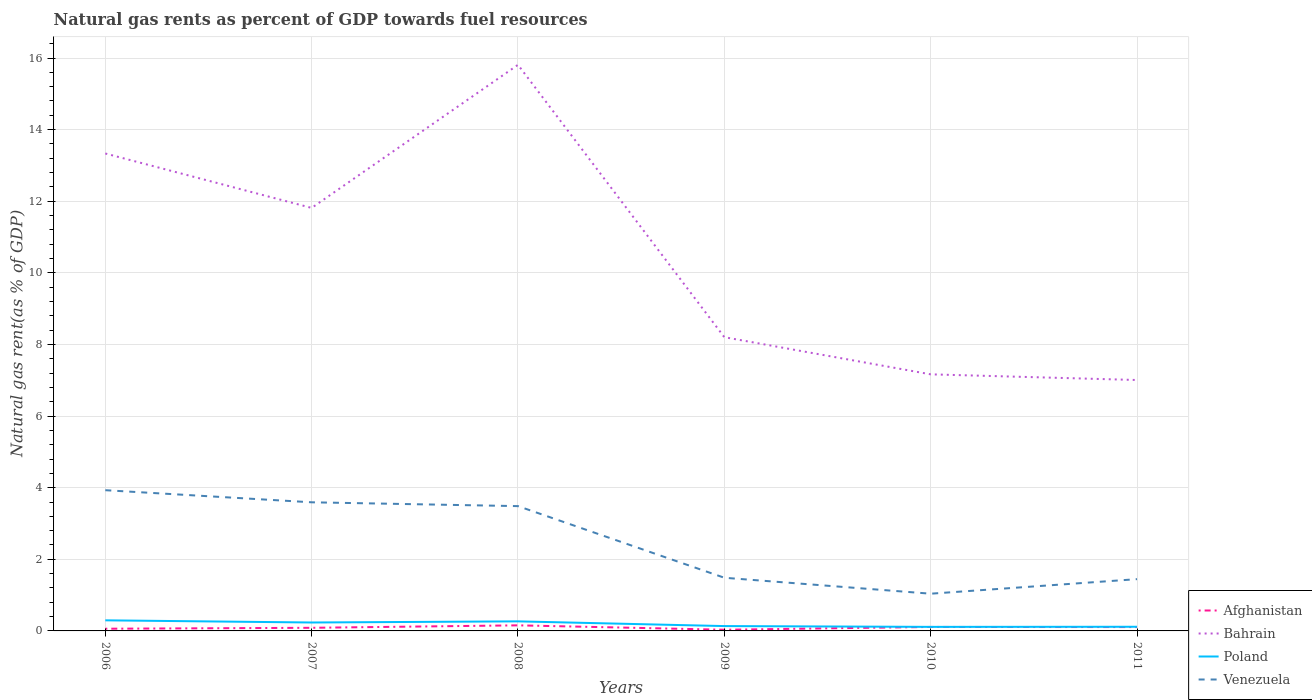Is the number of lines equal to the number of legend labels?
Your answer should be very brief. Yes. Across all years, what is the maximum natural gas rent in Bahrain?
Your answer should be compact. 7.01. What is the total natural gas rent in Venezuela in the graph?
Offer a terse response. 2.55. What is the difference between the highest and the second highest natural gas rent in Venezuela?
Keep it short and to the point. 2.89. What is the difference between the highest and the lowest natural gas rent in Poland?
Your response must be concise. 3. Is the natural gas rent in Afghanistan strictly greater than the natural gas rent in Bahrain over the years?
Your response must be concise. Yes. How many years are there in the graph?
Ensure brevity in your answer.  6. What is the difference between two consecutive major ticks on the Y-axis?
Provide a short and direct response. 2. Are the values on the major ticks of Y-axis written in scientific E-notation?
Ensure brevity in your answer.  No. Does the graph contain any zero values?
Make the answer very short. No. Does the graph contain grids?
Give a very brief answer. Yes. Where does the legend appear in the graph?
Provide a short and direct response. Bottom right. How many legend labels are there?
Your answer should be very brief. 4. What is the title of the graph?
Your response must be concise. Natural gas rents as percent of GDP towards fuel resources. Does "Seychelles" appear as one of the legend labels in the graph?
Make the answer very short. No. What is the label or title of the Y-axis?
Ensure brevity in your answer.  Natural gas rent(as % of GDP). What is the Natural gas rent(as % of GDP) of Afghanistan in 2006?
Make the answer very short. 0.06. What is the Natural gas rent(as % of GDP) in Bahrain in 2006?
Provide a succinct answer. 13.33. What is the Natural gas rent(as % of GDP) of Poland in 2006?
Your response must be concise. 0.3. What is the Natural gas rent(as % of GDP) of Venezuela in 2006?
Your answer should be very brief. 3.93. What is the Natural gas rent(as % of GDP) in Afghanistan in 2007?
Provide a succinct answer. 0.09. What is the Natural gas rent(as % of GDP) of Bahrain in 2007?
Your answer should be compact. 11.81. What is the Natural gas rent(as % of GDP) of Poland in 2007?
Your response must be concise. 0.24. What is the Natural gas rent(as % of GDP) of Venezuela in 2007?
Your answer should be compact. 3.59. What is the Natural gas rent(as % of GDP) in Afghanistan in 2008?
Provide a short and direct response. 0.16. What is the Natural gas rent(as % of GDP) of Bahrain in 2008?
Give a very brief answer. 15.81. What is the Natural gas rent(as % of GDP) of Poland in 2008?
Give a very brief answer. 0.27. What is the Natural gas rent(as % of GDP) in Venezuela in 2008?
Keep it short and to the point. 3.49. What is the Natural gas rent(as % of GDP) in Afghanistan in 2009?
Keep it short and to the point. 0.03. What is the Natural gas rent(as % of GDP) in Bahrain in 2009?
Your answer should be very brief. 8.2. What is the Natural gas rent(as % of GDP) in Poland in 2009?
Provide a short and direct response. 0.14. What is the Natural gas rent(as % of GDP) of Venezuela in 2009?
Provide a succinct answer. 1.48. What is the Natural gas rent(as % of GDP) of Afghanistan in 2010?
Offer a very short reply. 0.11. What is the Natural gas rent(as % of GDP) of Bahrain in 2010?
Your answer should be very brief. 7.17. What is the Natural gas rent(as % of GDP) of Poland in 2010?
Your answer should be very brief. 0.11. What is the Natural gas rent(as % of GDP) in Venezuela in 2010?
Offer a terse response. 1.04. What is the Natural gas rent(as % of GDP) in Afghanistan in 2011?
Your answer should be compact. 0.11. What is the Natural gas rent(as % of GDP) in Bahrain in 2011?
Provide a succinct answer. 7.01. What is the Natural gas rent(as % of GDP) in Poland in 2011?
Your answer should be very brief. 0.12. What is the Natural gas rent(as % of GDP) in Venezuela in 2011?
Offer a terse response. 1.45. Across all years, what is the maximum Natural gas rent(as % of GDP) of Afghanistan?
Keep it short and to the point. 0.16. Across all years, what is the maximum Natural gas rent(as % of GDP) in Bahrain?
Make the answer very short. 15.81. Across all years, what is the maximum Natural gas rent(as % of GDP) in Poland?
Provide a short and direct response. 0.3. Across all years, what is the maximum Natural gas rent(as % of GDP) of Venezuela?
Your response must be concise. 3.93. Across all years, what is the minimum Natural gas rent(as % of GDP) in Afghanistan?
Your answer should be compact. 0.03. Across all years, what is the minimum Natural gas rent(as % of GDP) in Bahrain?
Make the answer very short. 7.01. Across all years, what is the minimum Natural gas rent(as % of GDP) in Poland?
Offer a terse response. 0.11. Across all years, what is the minimum Natural gas rent(as % of GDP) in Venezuela?
Provide a succinct answer. 1.04. What is the total Natural gas rent(as % of GDP) of Afghanistan in the graph?
Keep it short and to the point. 0.56. What is the total Natural gas rent(as % of GDP) in Bahrain in the graph?
Make the answer very short. 63.33. What is the total Natural gas rent(as % of GDP) of Poland in the graph?
Offer a terse response. 1.16. What is the total Natural gas rent(as % of GDP) of Venezuela in the graph?
Your answer should be very brief. 14.98. What is the difference between the Natural gas rent(as % of GDP) of Afghanistan in 2006 and that in 2007?
Make the answer very short. -0.03. What is the difference between the Natural gas rent(as % of GDP) of Bahrain in 2006 and that in 2007?
Provide a short and direct response. 1.52. What is the difference between the Natural gas rent(as % of GDP) in Poland in 2006 and that in 2007?
Keep it short and to the point. 0.06. What is the difference between the Natural gas rent(as % of GDP) of Venezuela in 2006 and that in 2007?
Your answer should be very brief. 0.34. What is the difference between the Natural gas rent(as % of GDP) of Afghanistan in 2006 and that in 2008?
Your response must be concise. -0.09. What is the difference between the Natural gas rent(as % of GDP) in Bahrain in 2006 and that in 2008?
Ensure brevity in your answer.  -2.48. What is the difference between the Natural gas rent(as % of GDP) of Poland in 2006 and that in 2008?
Provide a short and direct response. 0.03. What is the difference between the Natural gas rent(as % of GDP) of Venezuela in 2006 and that in 2008?
Offer a terse response. 0.44. What is the difference between the Natural gas rent(as % of GDP) in Afghanistan in 2006 and that in 2009?
Ensure brevity in your answer.  0.03. What is the difference between the Natural gas rent(as % of GDP) of Bahrain in 2006 and that in 2009?
Give a very brief answer. 5.13. What is the difference between the Natural gas rent(as % of GDP) in Poland in 2006 and that in 2009?
Offer a terse response. 0.16. What is the difference between the Natural gas rent(as % of GDP) of Venezuela in 2006 and that in 2009?
Make the answer very short. 2.45. What is the difference between the Natural gas rent(as % of GDP) in Afghanistan in 2006 and that in 2010?
Provide a succinct answer. -0.05. What is the difference between the Natural gas rent(as % of GDP) of Bahrain in 2006 and that in 2010?
Offer a very short reply. 6.17. What is the difference between the Natural gas rent(as % of GDP) in Poland in 2006 and that in 2010?
Provide a succinct answer. 0.18. What is the difference between the Natural gas rent(as % of GDP) of Venezuela in 2006 and that in 2010?
Your response must be concise. 2.89. What is the difference between the Natural gas rent(as % of GDP) of Afghanistan in 2006 and that in 2011?
Offer a terse response. -0.05. What is the difference between the Natural gas rent(as % of GDP) of Bahrain in 2006 and that in 2011?
Provide a short and direct response. 6.33. What is the difference between the Natural gas rent(as % of GDP) in Poland in 2006 and that in 2011?
Keep it short and to the point. 0.18. What is the difference between the Natural gas rent(as % of GDP) in Venezuela in 2006 and that in 2011?
Provide a succinct answer. 2.48. What is the difference between the Natural gas rent(as % of GDP) in Afghanistan in 2007 and that in 2008?
Provide a short and direct response. -0.07. What is the difference between the Natural gas rent(as % of GDP) of Bahrain in 2007 and that in 2008?
Keep it short and to the point. -4. What is the difference between the Natural gas rent(as % of GDP) of Poland in 2007 and that in 2008?
Give a very brief answer. -0.03. What is the difference between the Natural gas rent(as % of GDP) in Venezuela in 2007 and that in 2008?
Provide a succinct answer. 0.11. What is the difference between the Natural gas rent(as % of GDP) of Afghanistan in 2007 and that in 2009?
Your answer should be compact. 0.05. What is the difference between the Natural gas rent(as % of GDP) of Bahrain in 2007 and that in 2009?
Your answer should be compact. 3.61. What is the difference between the Natural gas rent(as % of GDP) in Poland in 2007 and that in 2009?
Make the answer very short. 0.1. What is the difference between the Natural gas rent(as % of GDP) in Venezuela in 2007 and that in 2009?
Provide a short and direct response. 2.11. What is the difference between the Natural gas rent(as % of GDP) in Afghanistan in 2007 and that in 2010?
Your answer should be compact. -0.02. What is the difference between the Natural gas rent(as % of GDP) of Bahrain in 2007 and that in 2010?
Provide a short and direct response. 4.65. What is the difference between the Natural gas rent(as % of GDP) of Poland in 2007 and that in 2010?
Your answer should be very brief. 0.12. What is the difference between the Natural gas rent(as % of GDP) of Venezuela in 2007 and that in 2010?
Your response must be concise. 2.55. What is the difference between the Natural gas rent(as % of GDP) of Afghanistan in 2007 and that in 2011?
Your answer should be compact. -0.02. What is the difference between the Natural gas rent(as % of GDP) in Bahrain in 2007 and that in 2011?
Offer a very short reply. 4.81. What is the difference between the Natural gas rent(as % of GDP) of Poland in 2007 and that in 2011?
Provide a short and direct response. 0.12. What is the difference between the Natural gas rent(as % of GDP) in Venezuela in 2007 and that in 2011?
Provide a short and direct response. 2.15. What is the difference between the Natural gas rent(as % of GDP) in Afghanistan in 2008 and that in 2009?
Give a very brief answer. 0.12. What is the difference between the Natural gas rent(as % of GDP) of Bahrain in 2008 and that in 2009?
Keep it short and to the point. 7.61. What is the difference between the Natural gas rent(as % of GDP) of Poland in 2008 and that in 2009?
Give a very brief answer. 0.13. What is the difference between the Natural gas rent(as % of GDP) in Venezuela in 2008 and that in 2009?
Offer a very short reply. 2. What is the difference between the Natural gas rent(as % of GDP) in Afghanistan in 2008 and that in 2010?
Keep it short and to the point. 0.04. What is the difference between the Natural gas rent(as % of GDP) of Bahrain in 2008 and that in 2010?
Your response must be concise. 8.64. What is the difference between the Natural gas rent(as % of GDP) in Poland in 2008 and that in 2010?
Offer a very short reply. 0.15. What is the difference between the Natural gas rent(as % of GDP) of Venezuela in 2008 and that in 2010?
Ensure brevity in your answer.  2.45. What is the difference between the Natural gas rent(as % of GDP) of Afghanistan in 2008 and that in 2011?
Give a very brief answer. 0.05. What is the difference between the Natural gas rent(as % of GDP) in Bahrain in 2008 and that in 2011?
Ensure brevity in your answer.  8.8. What is the difference between the Natural gas rent(as % of GDP) of Poland in 2008 and that in 2011?
Offer a very short reply. 0.15. What is the difference between the Natural gas rent(as % of GDP) of Venezuela in 2008 and that in 2011?
Offer a very short reply. 2.04. What is the difference between the Natural gas rent(as % of GDP) in Afghanistan in 2009 and that in 2010?
Offer a very short reply. -0.08. What is the difference between the Natural gas rent(as % of GDP) in Bahrain in 2009 and that in 2010?
Provide a short and direct response. 1.04. What is the difference between the Natural gas rent(as % of GDP) in Poland in 2009 and that in 2010?
Keep it short and to the point. 0.02. What is the difference between the Natural gas rent(as % of GDP) of Venezuela in 2009 and that in 2010?
Provide a succinct answer. 0.45. What is the difference between the Natural gas rent(as % of GDP) in Afghanistan in 2009 and that in 2011?
Offer a very short reply. -0.07. What is the difference between the Natural gas rent(as % of GDP) in Bahrain in 2009 and that in 2011?
Give a very brief answer. 1.2. What is the difference between the Natural gas rent(as % of GDP) of Poland in 2009 and that in 2011?
Your response must be concise. 0.02. What is the difference between the Natural gas rent(as % of GDP) of Venezuela in 2009 and that in 2011?
Provide a succinct answer. 0.04. What is the difference between the Natural gas rent(as % of GDP) of Afghanistan in 2010 and that in 2011?
Give a very brief answer. 0. What is the difference between the Natural gas rent(as % of GDP) in Bahrain in 2010 and that in 2011?
Offer a terse response. 0.16. What is the difference between the Natural gas rent(as % of GDP) of Poland in 2010 and that in 2011?
Offer a very short reply. -0. What is the difference between the Natural gas rent(as % of GDP) in Venezuela in 2010 and that in 2011?
Give a very brief answer. -0.41. What is the difference between the Natural gas rent(as % of GDP) in Afghanistan in 2006 and the Natural gas rent(as % of GDP) in Bahrain in 2007?
Offer a very short reply. -11.75. What is the difference between the Natural gas rent(as % of GDP) in Afghanistan in 2006 and the Natural gas rent(as % of GDP) in Poland in 2007?
Offer a very short reply. -0.17. What is the difference between the Natural gas rent(as % of GDP) of Afghanistan in 2006 and the Natural gas rent(as % of GDP) of Venezuela in 2007?
Your response must be concise. -3.53. What is the difference between the Natural gas rent(as % of GDP) in Bahrain in 2006 and the Natural gas rent(as % of GDP) in Poland in 2007?
Your answer should be compact. 13.1. What is the difference between the Natural gas rent(as % of GDP) in Bahrain in 2006 and the Natural gas rent(as % of GDP) in Venezuela in 2007?
Offer a very short reply. 9.74. What is the difference between the Natural gas rent(as % of GDP) in Poland in 2006 and the Natural gas rent(as % of GDP) in Venezuela in 2007?
Give a very brief answer. -3.3. What is the difference between the Natural gas rent(as % of GDP) in Afghanistan in 2006 and the Natural gas rent(as % of GDP) in Bahrain in 2008?
Your answer should be very brief. -15.75. What is the difference between the Natural gas rent(as % of GDP) of Afghanistan in 2006 and the Natural gas rent(as % of GDP) of Poland in 2008?
Provide a short and direct response. -0.21. What is the difference between the Natural gas rent(as % of GDP) in Afghanistan in 2006 and the Natural gas rent(as % of GDP) in Venezuela in 2008?
Keep it short and to the point. -3.42. What is the difference between the Natural gas rent(as % of GDP) in Bahrain in 2006 and the Natural gas rent(as % of GDP) in Poland in 2008?
Offer a very short reply. 13.07. What is the difference between the Natural gas rent(as % of GDP) of Bahrain in 2006 and the Natural gas rent(as % of GDP) of Venezuela in 2008?
Your answer should be very brief. 9.85. What is the difference between the Natural gas rent(as % of GDP) in Poland in 2006 and the Natural gas rent(as % of GDP) in Venezuela in 2008?
Make the answer very short. -3.19. What is the difference between the Natural gas rent(as % of GDP) of Afghanistan in 2006 and the Natural gas rent(as % of GDP) of Bahrain in 2009?
Provide a succinct answer. -8.14. What is the difference between the Natural gas rent(as % of GDP) of Afghanistan in 2006 and the Natural gas rent(as % of GDP) of Poland in 2009?
Your response must be concise. -0.07. What is the difference between the Natural gas rent(as % of GDP) of Afghanistan in 2006 and the Natural gas rent(as % of GDP) of Venezuela in 2009?
Your answer should be compact. -1.42. What is the difference between the Natural gas rent(as % of GDP) in Bahrain in 2006 and the Natural gas rent(as % of GDP) in Poland in 2009?
Provide a succinct answer. 13.2. What is the difference between the Natural gas rent(as % of GDP) of Bahrain in 2006 and the Natural gas rent(as % of GDP) of Venezuela in 2009?
Your answer should be very brief. 11.85. What is the difference between the Natural gas rent(as % of GDP) in Poland in 2006 and the Natural gas rent(as % of GDP) in Venezuela in 2009?
Keep it short and to the point. -1.19. What is the difference between the Natural gas rent(as % of GDP) in Afghanistan in 2006 and the Natural gas rent(as % of GDP) in Bahrain in 2010?
Make the answer very short. -7.1. What is the difference between the Natural gas rent(as % of GDP) of Afghanistan in 2006 and the Natural gas rent(as % of GDP) of Poland in 2010?
Ensure brevity in your answer.  -0.05. What is the difference between the Natural gas rent(as % of GDP) in Afghanistan in 2006 and the Natural gas rent(as % of GDP) in Venezuela in 2010?
Provide a succinct answer. -0.98. What is the difference between the Natural gas rent(as % of GDP) of Bahrain in 2006 and the Natural gas rent(as % of GDP) of Poland in 2010?
Your answer should be very brief. 13.22. What is the difference between the Natural gas rent(as % of GDP) of Bahrain in 2006 and the Natural gas rent(as % of GDP) of Venezuela in 2010?
Provide a short and direct response. 12.29. What is the difference between the Natural gas rent(as % of GDP) in Poland in 2006 and the Natural gas rent(as % of GDP) in Venezuela in 2010?
Ensure brevity in your answer.  -0.74. What is the difference between the Natural gas rent(as % of GDP) of Afghanistan in 2006 and the Natural gas rent(as % of GDP) of Bahrain in 2011?
Your answer should be compact. -6.95. What is the difference between the Natural gas rent(as % of GDP) of Afghanistan in 2006 and the Natural gas rent(as % of GDP) of Poland in 2011?
Your response must be concise. -0.05. What is the difference between the Natural gas rent(as % of GDP) of Afghanistan in 2006 and the Natural gas rent(as % of GDP) of Venezuela in 2011?
Give a very brief answer. -1.38. What is the difference between the Natural gas rent(as % of GDP) of Bahrain in 2006 and the Natural gas rent(as % of GDP) of Poland in 2011?
Ensure brevity in your answer.  13.22. What is the difference between the Natural gas rent(as % of GDP) in Bahrain in 2006 and the Natural gas rent(as % of GDP) in Venezuela in 2011?
Keep it short and to the point. 11.89. What is the difference between the Natural gas rent(as % of GDP) of Poland in 2006 and the Natural gas rent(as % of GDP) of Venezuela in 2011?
Offer a very short reply. -1.15. What is the difference between the Natural gas rent(as % of GDP) of Afghanistan in 2007 and the Natural gas rent(as % of GDP) of Bahrain in 2008?
Offer a terse response. -15.72. What is the difference between the Natural gas rent(as % of GDP) in Afghanistan in 2007 and the Natural gas rent(as % of GDP) in Poland in 2008?
Provide a short and direct response. -0.18. What is the difference between the Natural gas rent(as % of GDP) of Afghanistan in 2007 and the Natural gas rent(as % of GDP) of Venezuela in 2008?
Make the answer very short. -3.4. What is the difference between the Natural gas rent(as % of GDP) of Bahrain in 2007 and the Natural gas rent(as % of GDP) of Poland in 2008?
Provide a short and direct response. 11.55. What is the difference between the Natural gas rent(as % of GDP) in Bahrain in 2007 and the Natural gas rent(as % of GDP) in Venezuela in 2008?
Your answer should be very brief. 8.33. What is the difference between the Natural gas rent(as % of GDP) in Poland in 2007 and the Natural gas rent(as % of GDP) in Venezuela in 2008?
Keep it short and to the point. -3.25. What is the difference between the Natural gas rent(as % of GDP) in Afghanistan in 2007 and the Natural gas rent(as % of GDP) in Bahrain in 2009?
Offer a very short reply. -8.12. What is the difference between the Natural gas rent(as % of GDP) in Afghanistan in 2007 and the Natural gas rent(as % of GDP) in Poland in 2009?
Give a very brief answer. -0.05. What is the difference between the Natural gas rent(as % of GDP) of Afghanistan in 2007 and the Natural gas rent(as % of GDP) of Venezuela in 2009?
Your answer should be compact. -1.4. What is the difference between the Natural gas rent(as % of GDP) of Bahrain in 2007 and the Natural gas rent(as % of GDP) of Poland in 2009?
Offer a very short reply. 11.68. What is the difference between the Natural gas rent(as % of GDP) in Bahrain in 2007 and the Natural gas rent(as % of GDP) in Venezuela in 2009?
Give a very brief answer. 10.33. What is the difference between the Natural gas rent(as % of GDP) of Poland in 2007 and the Natural gas rent(as % of GDP) of Venezuela in 2009?
Your response must be concise. -1.25. What is the difference between the Natural gas rent(as % of GDP) of Afghanistan in 2007 and the Natural gas rent(as % of GDP) of Bahrain in 2010?
Ensure brevity in your answer.  -7.08. What is the difference between the Natural gas rent(as % of GDP) of Afghanistan in 2007 and the Natural gas rent(as % of GDP) of Poland in 2010?
Provide a succinct answer. -0.03. What is the difference between the Natural gas rent(as % of GDP) in Afghanistan in 2007 and the Natural gas rent(as % of GDP) in Venezuela in 2010?
Give a very brief answer. -0.95. What is the difference between the Natural gas rent(as % of GDP) of Bahrain in 2007 and the Natural gas rent(as % of GDP) of Poland in 2010?
Your answer should be very brief. 11.7. What is the difference between the Natural gas rent(as % of GDP) of Bahrain in 2007 and the Natural gas rent(as % of GDP) of Venezuela in 2010?
Make the answer very short. 10.77. What is the difference between the Natural gas rent(as % of GDP) in Poland in 2007 and the Natural gas rent(as % of GDP) in Venezuela in 2010?
Offer a terse response. -0.8. What is the difference between the Natural gas rent(as % of GDP) in Afghanistan in 2007 and the Natural gas rent(as % of GDP) in Bahrain in 2011?
Ensure brevity in your answer.  -6.92. What is the difference between the Natural gas rent(as % of GDP) in Afghanistan in 2007 and the Natural gas rent(as % of GDP) in Poland in 2011?
Offer a very short reply. -0.03. What is the difference between the Natural gas rent(as % of GDP) in Afghanistan in 2007 and the Natural gas rent(as % of GDP) in Venezuela in 2011?
Your response must be concise. -1.36. What is the difference between the Natural gas rent(as % of GDP) in Bahrain in 2007 and the Natural gas rent(as % of GDP) in Poland in 2011?
Offer a very short reply. 11.7. What is the difference between the Natural gas rent(as % of GDP) in Bahrain in 2007 and the Natural gas rent(as % of GDP) in Venezuela in 2011?
Offer a very short reply. 10.37. What is the difference between the Natural gas rent(as % of GDP) in Poland in 2007 and the Natural gas rent(as % of GDP) in Venezuela in 2011?
Offer a terse response. -1.21. What is the difference between the Natural gas rent(as % of GDP) of Afghanistan in 2008 and the Natural gas rent(as % of GDP) of Bahrain in 2009?
Keep it short and to the point. -8.05. What is the difference between the Natural gas rent(as % of GDP) of Afghanistan in 2008 and the Natural gas rent(as % of GDP) of Poland in 2009?
Provide a succinct answer. 0.02. What is the difference between the Natural gas rent(as % of GDP) of Afghanistan in 2008 and the Natural gas rent(as % of GDP) of Venezuela in 2009?
Offer a terse response. -1.33. What is the difference between the Natural gas rent(as % of GDP) of Bahrain in 2008 and the Natural gas rent(as % of GDP) of Poland in 2009?
Your answer should be very brief. 15.67. What is the difference between the Natural gas rent(as % of GDP) in Bahrain in 2008 and the Natural gas rent(as % of GDP) in Venezuela in 2009?
Keep it short and to the point. 14.32. What is the difference between the Natural gas rent(as % of GDP) of Poland in 2008 and the Natural gas rent(as % of GDP) of Venezuela in 2009?
Offer a very short reply. -1.22. What is the difference between the Natural gas rent(as % of GDP) in Afghanistan in 2008 and the Natural gas rent(as % of GDP) in Bahrain in 2010?
Keep it short and to the point. -7.01. What is the difference between the Natural gas rent(as % of GDP) in Afghanistan in 2008 and the Natural gas rent(as % of GDP) in Poland in 2010?
Your answer should be very brief. 0.04. What is the difference between the Natural gas rent(as % of GDP) in Afghanistan in 2008 and the Natural gas rent(as % of GDP) in Venezuela in 2010?
Your answer should be compact. -0.88. What is the difference between the Natural gas rent(as % of GDP) of Bahrain in 2008 and the Natural gas rent(as % of GDP) of Poland in 2010?
Your answer should be very brief. 15.7. What is the difference between the Natural gas rent(as % of GDP) of Bahrain in 2008 and the Natural gas rent(as % of GDP) of Venezuela in 2010?
Your response must be concise. 14.77. What is the difference between the Natural gas rent(as % of GDP) of Poland in 2008 and the Natural gas rent(as % of GDP) of Venezuela in 2010?
Make the answer very short. -0.77. What is the difference between the Natural gas rent(as % of GDP) of Afghanistan in 2008 and the Natural gas rent(as % of GDP) of Bahrain in 2011?
Provide a succinct answer. -6.85. What is the difference between the Natural gas rent(as % of GDP) in Afghanistan in 2008 and the Natural gas rent(as % of GDP) in Poland in 2011?
Your answer should be compact. 0.04. What is the difference between the Natural gas rent(as % of GDP) of Afghanistan in 2008 and the Natural gas rent(as % of GDP) of Venezuela in 2011?
Give a very brief answer. -1.29. What is the difference between the Natural gas rent(as % of GDP) in Bahrain in 2008 and the Natural gas rent(as % of GDP) in Poland in 2011?
Provide a short and direct response. 15.69. What is the difference between the Natural gas rent(as % of GDP) of Bahrain in 2008 and the Natural gas rent(as % of GDP) of Venezuela in 2011?
Offer a very short reply. 14.36. What is the difference between the Natural gas rent(as % of GDP) of Poland in 2008 and the Natural gas rent(as % of GDP) of Venezuela in 2011?
Ensure brevity in your answer.  -1.18. What is the difference between the Natural gas rent(as % of GDP) in Afghanistan in 2009 and the Natural gas rent(as % of GDP) in Bahrain in 2010?
Give a very brief answer. -7.13. What is the difference between the Natural gas rent(as % of GDP) of Afghanistan in 2009 and the Natural gas rent(as % of GDP) of Poland in 2010?
Your answer should be compact. -0.08. What is the difference between the Natural gas rent(as % of GDP) of Afghanistan in 2009 and the Natural gas rent(as % of GDP) of Venezuela in 2010?
Make the answer very short. -1.01. What is the difference between the Natural gas rent(as % of GDP) of Bahrain in 2009 and the Natural gas rent(as % of GDP) of Poland in 2010?
Your answer should be very brief. 8.09. What is the difference between the Natural gas rent(as % of GDP) of Bahrain in 2009 and the Natural gas rent(as % of GDP) of Venezuela in 2010?
Your response must be concise. 7.16. What is the difference between the Natural gas rent(as % of GDP) of Poland in 2009 and the Natural gas rent(as % of GDP) of Venezuela in 2010?
Provide a succinct answer. -0.9. What is the difference between the Natural gas rent(as % of GDP) in Afghanistan in 2009 and the Natural gas rent(as % of GDP) in Bahrain in 2011?
Your answer should be compact. -6.97. What is the difference between the Natural gas rent(as % of GDP) of Afghanistan in 2009 and the Natural gas rent(as % of GDP) of Poland in 2011?
Make the answer very short. -0.08. What is the difference between the Natural gas rent(as % of GDP) in Afghanistan in 2009 and the Natural gas rent(as % of GDP) in Venezuela in 2011?
Provide a succinct answer. -1.41. What is the difference between the Natural gas rent(as % of GDP) of Bahrain in 2009 and the Natural gas rent(as % of GDP) of Poland in 2011?
Ensure brevity in your answer.  8.09. What is the difference between the Natural gas rent(as % of GDP) of Bahrain in 2009 and the Natural gas rent(as % of GDP) of Venezuela in 2011?
Make the answer very short. 6.76. What is the difference between the Natural gas rent(as % of GDP) in Poland in 2009 and the Natural gas rent(as % of GDP) in Venezuela in 2011?
Offer a very short reply. -1.31. What is the difference between the Natural gas rent(as % of GDP) of Afghanistan in 2010 and the Natural gas rent(as % of GDP) of Bahrain in 2011?
Offer a very short reply. -6.9. What is the difference between the Natural gas rent(as % of GDP) of Afghanistan in 2010 and the Natural gas rent(as % of GDP) of Poland in 2011?
Your response must be concise. -0.01. What is the difference between the Natural gas rent(as % of GDP) in Afghanistan in 2010 and the Natural gas rent(as % of GDP) in Venezuela in 2011?
Your response must be concise. -1.34. What is the difference between the Natural gas rent(as % of GDP) in Bahrain in 2010 and the Natural gas rent(as % of GDP) in Poland in 2011?
Offer a very short reply. 7.05. What is the difference between the Natural gas rent(as % of GDP) of Bahrain in 2010 and the Natural gas rent(as % of GDP) of Venezuela in 2011?
Provide a succinct answer. 5.72. What is the difference between the Natural gas rent(as % of GDP) in Poland in 2010 and the Natural gas rent(as % of GDP) in Venezuela in 2011?
Your answer should be very brief. -1.33. What is the average Natural gas rent(as % of GDP) of Afghanistan per year?
Ensure brevity in your answer.  0.09. What is the average Natural gas rent(as % of GDP) in Bahrain per year?
Offer a terse response. 10.56. What is the average Natural gas rent(as % of GDP) of Poland per year?
Your answer should be compact. 0.19. What is the average Natural gas rent(as % of GDP) in Venezuela per year?
Give a very brief answer. 2.5. In the year 2006, what is the difference between the Natural gas rent(as % of GDP) of Afghanistan and Natural gas rent(as % of GDP) of Bahrain?
Offer a very short reply. -13.27. In the year 2006, what is the difference between the Natural gas rent(as % of GDP) in Afghanistan and Natural gas rent(as % of GDP) in Poland?
Make the answer very short. -0.23. In the year 2006, what is the difference between the Natural gas rent(as % of GDP) of Afghanistan and Natural gas rent(as % of GDP) of Venezuela?
Make the answer very short. -3.87. In the year 2006, what is the difference between the Natural gas rent(as % of GDP) of Bahrain and Natural gas rent(as % of GDP) of Poland?
Keep it short and to the point. 13.04. In the year 2006, what is the difference between the Natural gas rent(as % of GDP) in Bahrain and Natural gas rent(as % of GDP) in Venezuela?
Your answer should be compact. 9.4. In the year 2006, what is the difference between the Natural gas rent(as % of GDP) of Poland and Natural gas rent(as % of GDP) of Venezuela?
Make the answer very short. -3.63. In the year 2007, what is the difference between the Natural gas rent(as % of GDP) in Afghanistan and Natural gas rent(as % of GDP) in Bahrain?
Offer a terse response. -11.73. In the year 2007, what is the difference between the Natural gas rent(as % of GDP) in Afghanistan and Natural gas rent(as % of GDP) in Poland?
Keep it short and to the point. -0.15. In the year 2007, what is the difference between the Natural gas rent(as % of GDP) of Afghanistan and Natural gas rent(as % of GDP) of Venezuela?
Keep it short and to the point. -3.5. In the year 2007, what is the difference between the Natural gas rent(as % of GDP) in Bahrain and Natural gas rent(as % of GDP) in Poland?
Your response must be concise. 11.58. In the year 2007, what is the difference between the Natural gas rent(as % of GDP) in Bahrain and Natural gas rent(as % of GDP) in Venezuela?
Offer a very short reply. 8.22. In the year 2007, what is the difference between the Natural gas rent(as % of GDP) of Poland and Natural gas rent(as % of GDP) of Venezuela?
Your response must be concise. -3.36. In the year 2008, what is the difference between the Natural gas rent(as % of GDP) of Afghanistan and Natural gas rent(as % of GDP) of Bahrain?
Give a very brief answer. -15.65. In the year 2008, what is the difference between the Natural gas rent(as % of GDP) in Afghanistan and Natural gas rent(as % of GDP) in Poland?
Provide a succinct answer. -0.11. In the year 2008, what is the difference between the Natural gas rent(as % of GDP) of Afghanistan and Natural gas rent(as % of GDP) of Venezuela?
Keep it short and to the point. -3.33. In the year 2008, what is the difference between the Natural gas rent(as % of GDP) of Bahrain and Natural gas rent(as % of GDP) of Poland?
Your answer should be compact. 15.54. In the year 2008, what is the difference between the Natural gas rent(as % of GDP) in Bahrain and Natural gas rent(as % of GDP) in Venezuela?
Your answer should be very brief. 12.32. In the year 2008, what is the difference between the Natural gas rent(as % of GDP) in Poland and Natural gas rent(as % of GDP) in Venezuela?
Keep it short and to the point. -3.22. In the year 2009, what is the difference between the Natural gas rent(as % of GDP) in Afghanistan and Natural gas rent(as % of GDP) in Bahrain?
Make the answer very short. -8.17. In the year 2009, what is the difference between the Natural gas rent(as % of GDP) in Afghanistan and Natural gas rent(as % of GDP) in Poland?
Your answer should be compact. -0.1. In the year 2009, what is the difference between the Natural gas rent(as % of GDP) of Afghanistan and Natural gas rent(as % of GDP) of Venezuela?
Offer a terse response. -1.45. In the year 2009, what is the difference between the Natural gas rent(as % of GDP) in Bahrain and Natural gas rent(as % of GDP) in Poland?
Ensure brevity in your answer.  8.07. In the year 2009, what is the difference between the Natural gas rent(as % of GDP) in Bahrain and Natural gas rent(as % of GDP) in Venezuela?
Make the answer very short. 6.72. In the year 2009, what is the difference between the Natural gas rent(as % of GDP) in Poland and Natural gas rent(as % of GDP) in Venezuela?
Give a very brief answer. -1.35. In the year 2010, what is the difference between the Natural gas rent(as % of GDP) of Afghanistan and Natural gas rent(as % of GDP) of Bahrain?
Make the answer very short. -7.05. In the year 2010, what is the difference between the Natural gas rent(as % of GDP) of Afghanistan and Natural gas rent(as % of GDP) of Poland?
Make the answer very short. -0. In the year 2010, what is the difference between the Natural gas rent(as % of GDP) of Afghanistan and Natural gas rent(as % of GDP) of Venezuela?
Offer a terse response. -0.93. In the year 2010, what is the difference between the Natural gas rent(as % of GDP) in Bahrain and Natural gas rent(as % of GDP) in Poland?
Make the answer very short. 7.05. In the year 2010, what is the difference between the Natural gas rent(as % of GDP) of Bahrain and Natural gas rent(as % of GDP) of Venezuela?
Ensure brevity in your answer.  6.13. In the year 2010, what is the difference between the Natural gas rent(as % of GDP) in Poland and Natural gas rent(as % of GDP) in Venezuela?
Provide a succinct answer. -0.93. In the year 2011, what is the difference between the Natural gas rent(as % of GDP) of Afghanistan and Natural gas rent(as % of GDP) of Bahrain?
Keep it short and to the point. -6.9. In the year 2011, what is the difference between the Natural gas rent(as % of GDP) in Afghanistan and Natural gas rent(as % of GDP) in Poland?
Your answer should be compact. -0.01. In the year 2011, what is the difference between the Natural gas rent(as % of GDP) in Afghanistan and Natural gas rent(as % of GDP) in Venezuela?
Keep it short and to the point. -1.34. In the year 2011, what is the difference between the Natural gas rent(as % of GDP) in Bahrain and Natural gas rent(as % of GDP) in Poland?
Offer a very short reply. 6.89. In the year 2011, what is the difference between the Natural gas rent(as % of GDP) in Bahrain and Natural gas rent(as % of GDP) in Venezuela?
Provide a short and direct response. 5.56. In the year 2011, what is the difference between the Natural gas rent(as % of GDP) of Poland and Natural gas rent(as % of GDP) of Venezuela?
Your answer should be very brief. -1.33. What is the ratio of the Natural gas rent(as % of GDP) in Afghanistan in 2006 to that in 2007?
Keep it short and to the point. 0.7. What is the ratio of the Natural gas rent(as % of GDP) in Bahrain in 2006 to that in 2007?
Provide a short and direct response. 1.13. What is the ratio of the Natural gas rent(as % of GDP) of Poland in 2006 to that in 2007?
Your answer should be compact. 1.26. What is the ratio of the Natural gas rent(as % of GDP) in Venezuela in 2006 to that in 2007?
Ensure brevity in your answer.  1.09. What is the ratio of the Natural gas rent(as % of GDP) of Afghanistan in 2006 to that in 2008?
Provide a succinct answer. 0.39. What is the ratio of the Natural gas rent(as % of GDP) of Bahrain in 2006 to that in 2008?
Offer a very short reply. 0.84. What is the ratio of the Natural gas rent(as % of GDP) in Poland in 2006 to that in 2008?
Offer a terse response. 1.11. What is the ratio of the Natural gas rent(as % of GDP) of Venezuela in 2006 to that in 2008?
Provide a short and direct response. 1.13. What is the ratio of the Natural gas rent(as % of GDP) in Afghanistan in 2006 to that in 2009?
Ensure brevity in your answer.  1.86. What is the ratio of the Natural gas rent(as % of GDP) of Bahrain in 2006 to that in 2009?
Offer a very short reply. 1.63. What is the ratio of the Natural gas rent(as % of GDP) in Poland in 2006 to that in 2009?
Offer a very short reply. 2.19. What is the ratio of the Natural gas rent(as % of GDP) of Venezuela in 2006 to that in 2009?
Offer a very short reply. 2.65. What is the ratio of the Natural gas rent(as % of GDP) of Afghanistan in 2006 to that in 2010?
Your response must be concise. 0.55. What is the ratio of the Natural gas rent(as % of GDP) of Bahrain in 2006 to that in 2010?
Your answer should be very brief. 1.86. What is the ratio of the Natural gas rent(as % of GDP) in Poland in 2006 to that in 2010?
Offer a very short reply. 2.62. What is the ratio of the Natural gas rent(as % of GDP) of Venezuela in 2006 to that in 2010?
Make the answer very short. 3.78. What is the ratio of the Natural gas rent(as % of GDP) in Afghanistan in 2006 to that in 2011?
Keep it short and to the point. 0.57. What is the ratio of the Natural gas rent(as % of GDP) of Bahrain in 2006 to that in 2011?
Your response must be concise. 1.9. What is the ratio of the Natural gas rent(as % of GDP) in Poland in 2006 to that in 2011?
Keep it short and to the point. 2.55. What is the ratio of the Natural gas rent(as % of GDP) in Venezuela in 2006 to that in 2011?
Your answer should be compact. 2.72. What is the ratio of the Natural gas rent(as % of GDP) of Afghanistan in 2007 to that in 2008?
Give a very brief answer. 0.56. What is the ratio of the Natural gas rent(as % of GDP) in Bahrain in 2007 to that in 2008?
Provide a short and direct response. 0.75. What is the ratio of the Natural gas rent(as % of GDP) of Poland in 2007 to that in 2008?
Keep it short and to the point. 0.88. What is the ratio of the Natural gas rent(as % of GDP) of Venezuela in 2007 to that in 2008?
Provide a succinct answer. 1.03. What is the ratio of the Natural gas rent(as % of GDP) in Afghanistan in 2007 to that in 2009?
Ensure brevity in your answer.  2.64. What is the ratio of the Natural gas rent(as % of GDP) in Bahrain in 2007 to that in 2009?
Ensure brevity in your answer.  1.44. What is the ratio of the Natural gas rent(as % of GDP) of Poland in 2007 to that in 2009?
Make the answer very short. 1.74. What is the ratio of the Natural gas rent(as % of GDP) in Venezuela in 2007 to that in 2009?
Offer a terse response. 2.42. What is the ratio of the Natural gas rent(as % of GDP) of Afghanistan in 2007 to that in 2010?
Offer a terse response. 0.79. What is the ratio of the Natural gas rent(as % of GDP) of Bahrain in 2007 to that in 2010?
Ensure brevity in your answer.  1.65. What is the ratio of the Natural gas rent(as % of GDP) of Poland in 2007 to that in 2010?
Your response must be concise. 2.08. What is the ratio of the Natural gas rent(as % of GDP) in Venezuela in 2007 to that in 2010?
Provide a short and direct response. 3.46. What is the ratio of the Natural gas rent(as % of GDP) of Afghanistan in 2007 to that in 2011?
Offer a terse response. 0.81. What is the ratio of the Natural gas rent(as % of GDP) in Bahrain in 2007 to that in 2011?
Your response must be concise. 1.69. What is the ratio of the Natural gas rent(as % of GDP) of Poland in 2007 to that in 2011?
Your answer should be compact. 2.02. What is the ratio of the Natural gas rent(as % of GDP) in Venezuela in 2007 to that in 2011?
Your response must be concise. 2.48. What is the ratio of the Natural gas rent(as % of GDP) of Afghanistan in 2008 to that in 2009?
Your answer should be compact. 4.72. What is the ratio of the Natural gas rent(as % of GDP) in Bahrain in 2008 to that in 2009?
Your answer should be very brief. 1.93. What is the ratio of the Natural gas rent(as % of GDP) of Poland in 2008 to that in 2009?
Ensure brevity in your answer.  1.97. What is the ratio of the Natural gas rent(as % of GDP) in Venezuela in 2008 to that in 2009?
Your answer should be compact. 2.35. What is the ratio of the Natural gas rent(as % of GDP) of Afghanistan in 2008 to that in 2010?
Your answer should be very brief. 1.4. What is the ratio of the Natural gas rent(as % of GDP) of Bahrain in 2008 to that in 2010?
Offer a very short reply. 2.21. What is the ratio of the Natural gas rent(as % of GDP) of Poland in 2008 to that in 2010?
Offer a terse response. 2.36. What is the ratio of the Natural gas rent(as % of GDP) in Venezuela in 2008 to that in 2010?
Ensure brevity in your answer.  3.35. What is the ratio of the Natural gas rent(as % of GDP) in Afghanistan in 2008 to that in 2011?
Your response must be concise. 1.45. What is the ratio of the Natural gas rent(as % of GDP) in Bahrain in 2008 to that in 2011?
Your answer should be compact. 2.26. What is the ratio of the Natural gas rent(as % of GDP) of Poland in 2008 to that in 2011?
Your response must be concise. 2.3. What is the ratio of the Natural gas rent(as % of GDP) in Venezuela in 2008 to that in 2011?
Your response must be concise. 2.41. What is the ratio of the Natural gas rent(as % of GDP) of Afghanistan in 2009 to that in 2010?
Your response must be concise. 0.3. What is the ratio of the Natural gas rent(as % of GDP) of Bahrain in 2009 to that in 2010?
Your answer should be compact. 1.14. What is the ratio of the Natural gas rent(as % of GDP) in Poland in 2009 to that in 2010?
Provide a succinct answer. 1.2. What is the ratio of the Natural gas rent(as % of GDP) in Venezuela in 2009 to that in 2010?
Give a very brief answer. 1.43. What is the ratio of the Natural gas rent(as % of GDP) of Afghanistan in 2009 to that in 2011?
Offer a very short reply. 0.31. What is the ratio of the Natural gas rent(as % of GDP) in Bahrain in 2009 to that in 2011?
Offer a terse response. 1.17. What is the ratio of the Natural gas rent(as % of GDP) of Poland in 2009 to that in 2011?
Provide a succinct answer. 1.17. What is the ratio of the Natural gas rent(as % of GDP) of Venezuela in 2009 to that in 2011?
Make the answer very short. 1.03. What is the ratio of the Natural gas rent(as % of GDP) in Afghanistan in 2010 to that in 2011?
Make the answer very short. 1.03. What is the ratio of the Natural gas rent(as % of GDP) of Bahrain in 2010 to that in 2011?
Your answer should be compact. 1.02. What is the ratio of the Natural gas rent(as % of GDP) of Poland in 2010 to that in 2011?
Keep it short and to the point. 0.97. What is the ratio of the Natural gas rent(as % of GDP) of Venezuela in 2010 to that in 2011?
Make the answer very short. 0.72. What is the difference between the highest and the second highest Natural gas rent(as % of GDP) of Afghanistan?
Your answer should be compact. 0.04. What is the difference between the highest and the second highest Natural gas rent(as % of GDP) of Bahrain?
Offer a very short reply. 2.48. What is the difference between the highest and the second highest Natural gas rent(as % of GDP) of Poland?
Your answer should be compact. 0.03. What is the difference between the highest and the second highest Natural gas rent(as % of GDP) of Venezuela?
Your response must be concise. 0.34. What is the difference between the highest and the lowest Natural gas rent(as % of GDP) in Afghanistan?
Ensure brevity in your answer.  0.12. What is the difference between the highest and the lowest Natural gas rent(as % of GDP) of Bahrain?
Provide a short and direct response. 8.8. What is the difference between the highest and the lowest Natural gas rent(as % of GDP) of Poland?
Your answer should be compact. 0.18. What is the difference between the highest and the lowest Natural gas rent(as % of GDP) in Venezuela?
Ensure brevity in your answer.  2.89. 